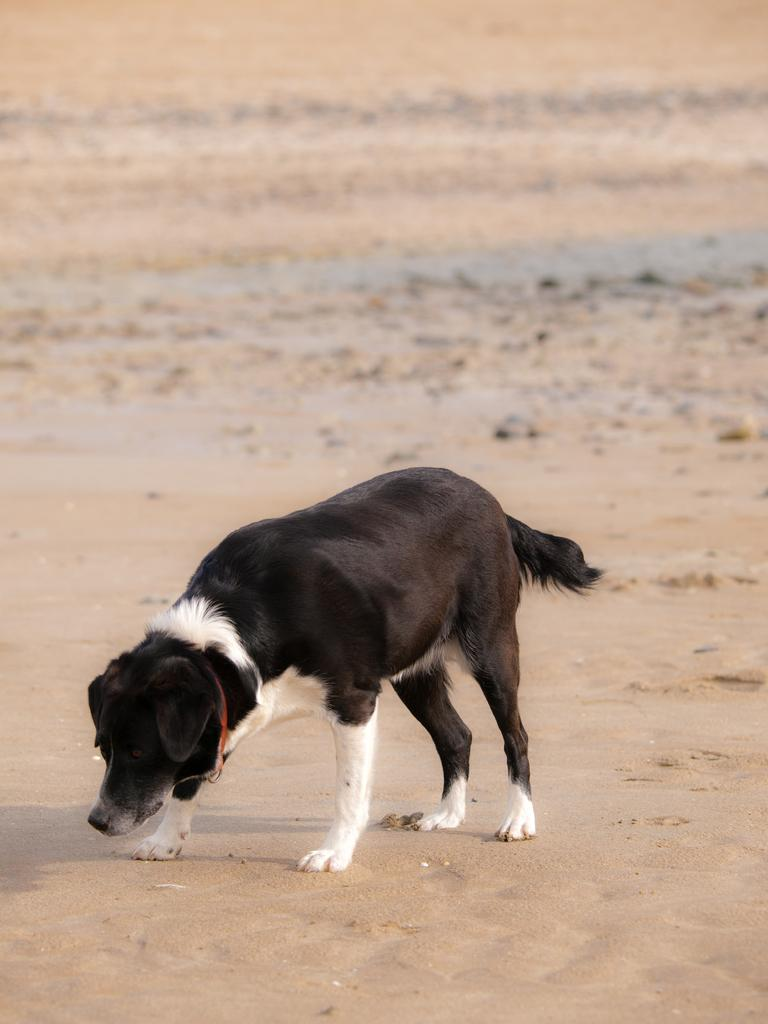What type of animal is in the image? There is a dog in the image. What is the dog doing in the image? The dog is standing. What colors can be seen on the dog in the image? The dog is black and white in color. What type of terrain is visible in the image? There is sand visible in the image. What type of glove is the dog wearing in the image? There is no glove present in the image, and the dog is not wearing any clothing or accessories. 